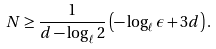<formula> <loc_0><loc_0><loc_500><loc_500>N \geq \frac { 1 } { d - \log _ { \ell } 2 } \left ( - \log _ { \ell } \epsilon + 3 d \right ) .</formula> 